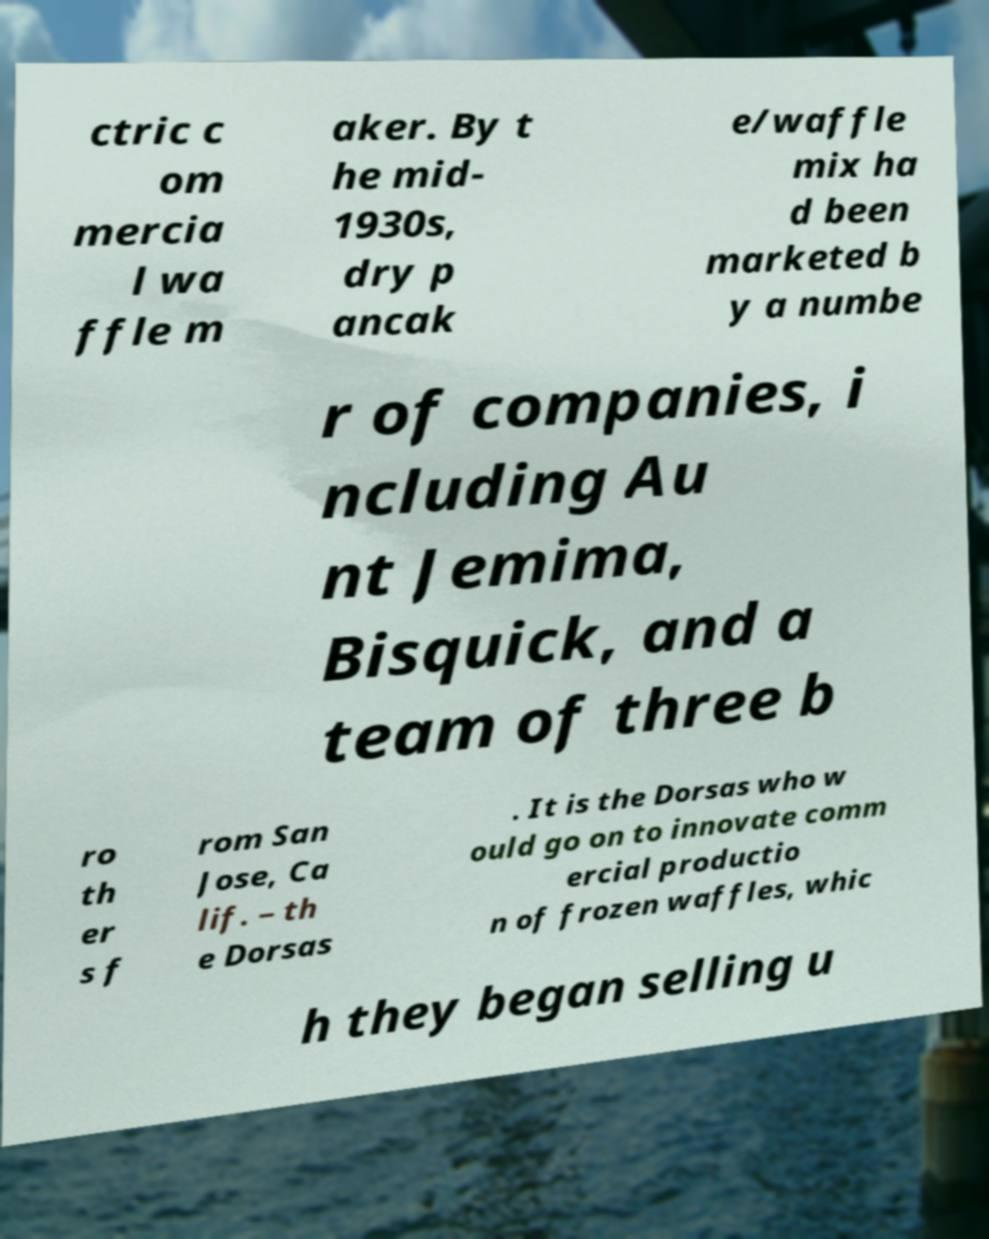Please read and relay the text visible in this image. What does it say? ctric c om mercia l wa ffle m aker. By t he mid- 1930s, dry p ancak e/waffle mix ha d been marketed b y a numbe r of companies, i ncluding Au nt Jemima, Bisquick, and a team of three b ro th er s f rom San Jose, Ca lif. – th e Dorsas . It is the Dorsas who w ould go on to innovate comm ercial productio n of frozen waffles, whic h they began selling u 